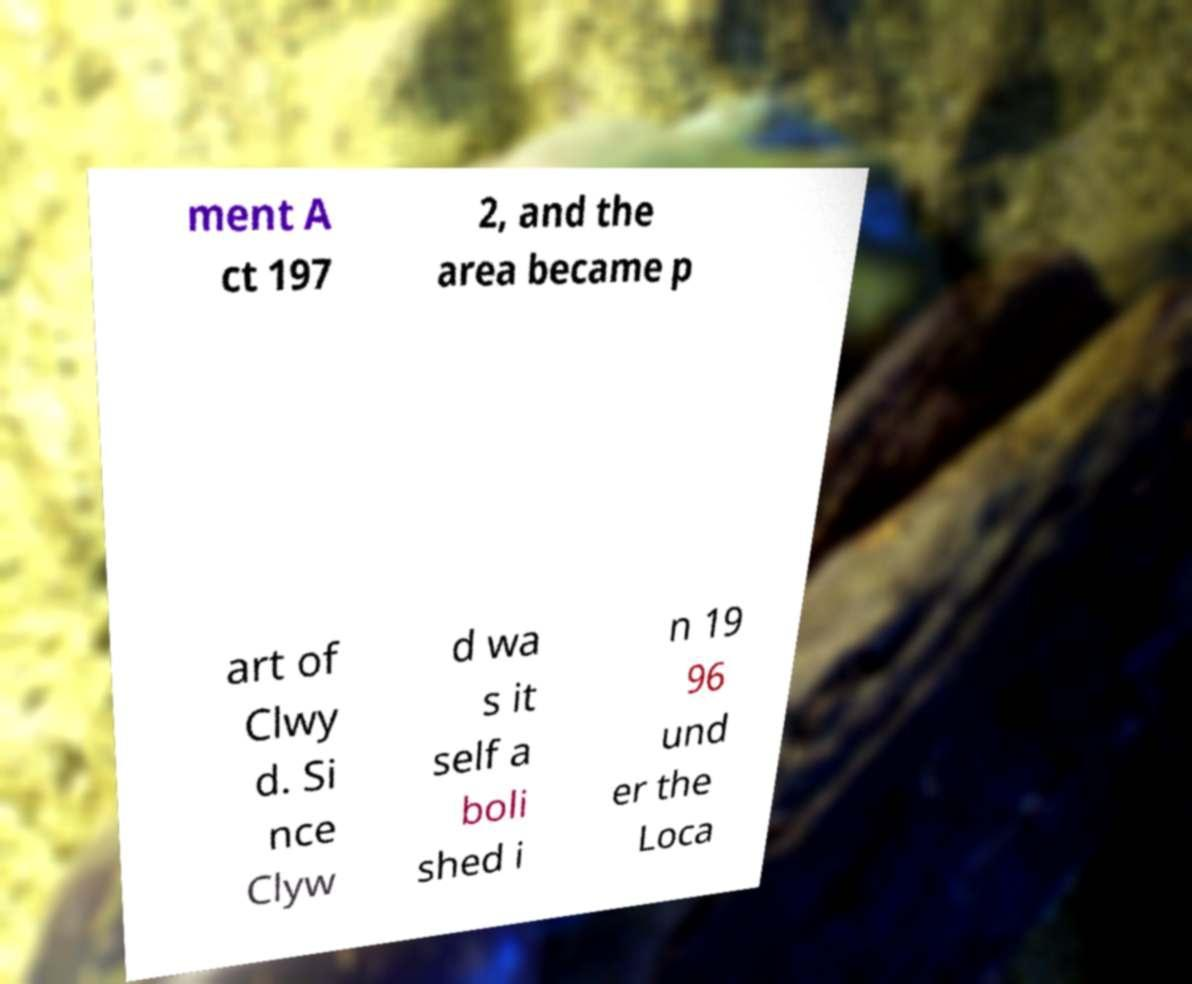Please identify and transcribe the text found in this image. ment A ct 197 2, and the area became p art of Clwy d. Si nce Clyw d wa s it self a boli shed i n 19 96 und er the Loca 